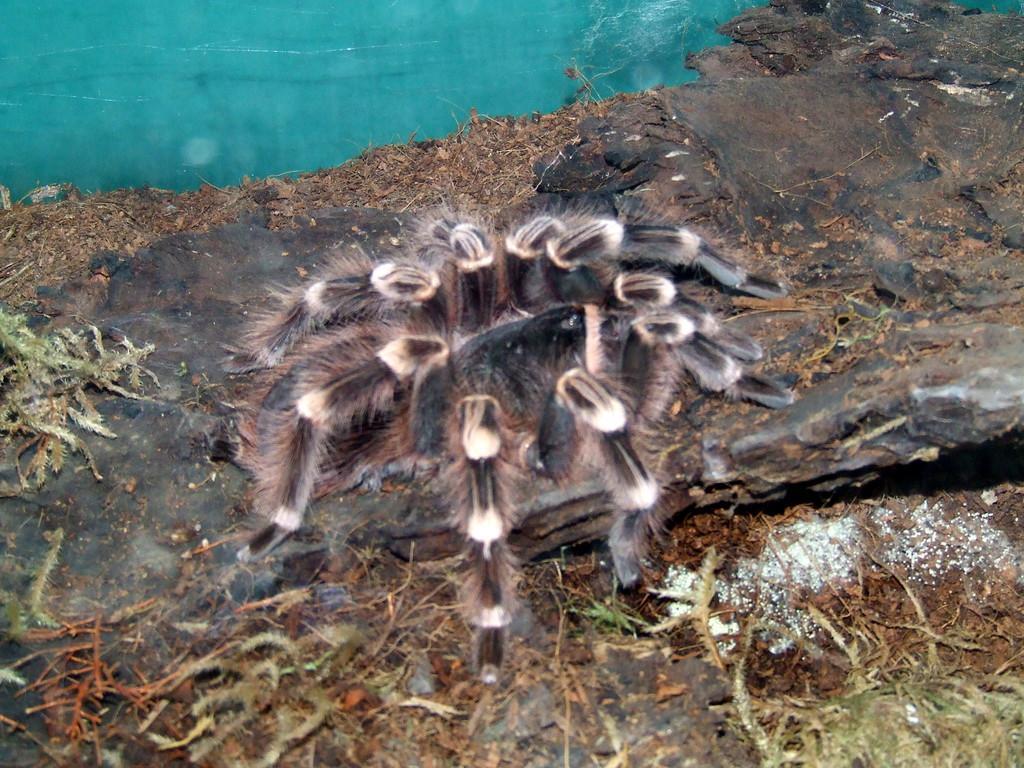In one or two sentences, can you explain what this image depicts? This image is an edited image. This image is taken outdoors. At the bottom of the image there is a ground with a few rocks on it. There are a few dry leaves on the ground. In the middle of the image there is a spider. At the top of the image there is a pond with water. 